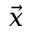<formula> <loc_0><loc_0><loc_500><loc_500>\vec { x }</formula> 